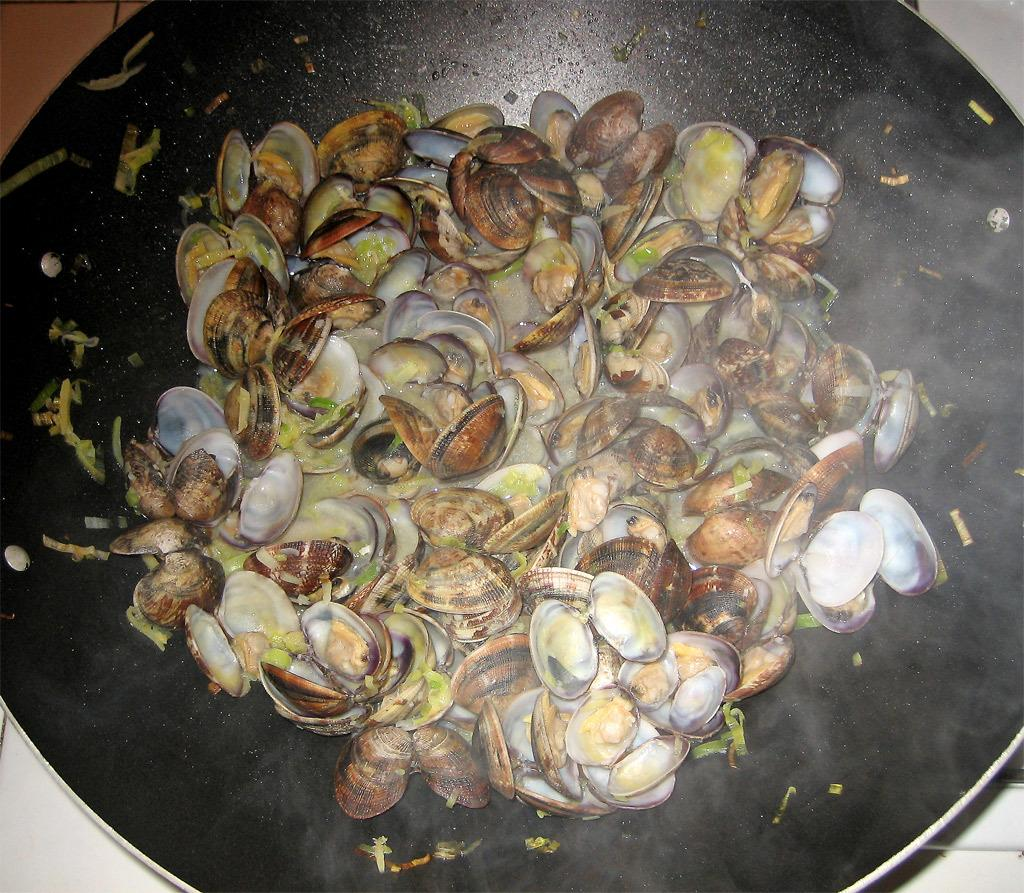What is in the pan that is visible in the image? There is a pan in the image, and it contains a food item. What type of food item is in the pan? The food item in the pan is made of mussels. What type of stew is being prepared in the pan? There is no stew being prepared in the pan; it contains mussels. How does the pan rest on the surface in the image? The pan does not rest on any surface in the image; it is not visible where it might be resting. 